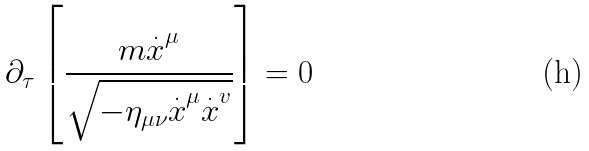Convert formula to latex. <formula><loc_0><loc_0><loc_500><loc_500>\partial _ { \tau } \left [ \frac { m \overset { . } { x } ^ { \mu } } { \sqrt { - \eta _ { \mu \nu } \overset { . } { x } ^ { \mu } \overset { . } { x } ^ { v } } } \right ] = 0</formula> 